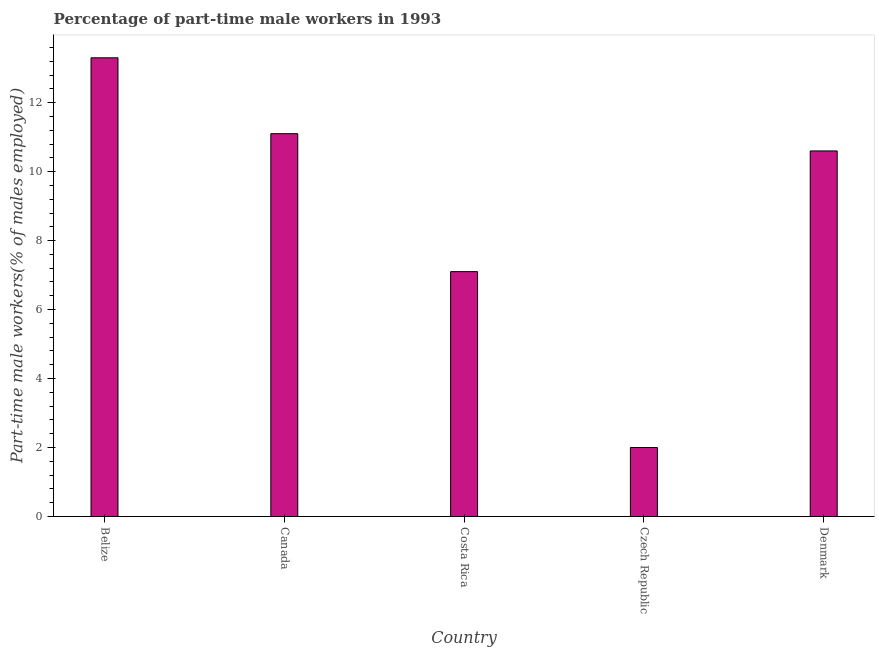Does the graph contain grids?
Provide a succinct answer. No. What is the title of the graph?
Ensure brevity in your answer.  Percentage of part-time male workers in 1993. What is the label or title of the Y-axis?
Provide a succinct answer. Part-time male workers(% of males employed). What is the percentage of part-time male workers in Costa Rica?
Offer a very short reply. 7.1. Across all countries, what is the maximum percentage of part-time male workers?
Ensure brevity in your answer.  13.3. Across all countries, what is the minimum percentage of part-time male workers?
Keep it short and to the point. 2. In which country was the percentage of part-time male workers maximum?
Your answer should be very brief. Belize. In which country was the percentage of part-time male workers minimum?
Make the answer very short. Czech Republic. What is the sum of the percentage of part-time male workers?
Your response must be concise. 44.1. What is the average percentage of part-time male workers per country?
Your answer should be very brief. 8.82. What is the median percentage of part-time male workers?
Offer a very short reply. 10.6. In how many countries, is the percentage of part-time male workers greater than 6.8 %?
Your answer should be very brief. 4. What is the ratio of the percentage of part-time male workers in Czech Republic to that in Denmark?
Provide a succinct answer. 0.19. Is the percentage of part-time male workers in Belize less than that in Canada?
Provide a succinct answer. No. What is the difference between the highest and the second highest percentage of part-time male workers?
Your answer should be compact. 2.2. Is the sum of the percentage of part-time male workers in Belize and Denmark greater than the maximum percentage of part-time male workers across all countries?
Ensure brevity in your answer.  Yes. What is the difference between the highest and the lowest percentage of part-time male workers?
Your response must be concise. 11.3. In how many countries, is the percentage of part-time male workers greater than the average percentage of part-time male workers taken over all countries?
Make the answer very short. 3. How many bars are there?
Offer a very short reply. 5. How many countries are there in the graph?
Offer a very short reply. 5. What is the difference between two consecutive major ticks on the Y-axis?
Your answer should be very brief. 2. Are the values on the major ticks of Y-axis written in scientific E-notation?
Provide a short and direct response. No. What is the Part-time male workers(% of males employed) of Belize?
Your answer should be very brief. 13.3. What is the Part-time male workers(% of males employed) in Canada?
Give a very brief answer. 11.1. What is the Part-time male workers(% of males employed) of Costa Rica?
Your response must be concise. 7.1. What is the Part-time male workers(% of males employed) of Czech Republic?
Your answer should be compact. 2. What is the Part-time male workers(% of males employed) in Denmark?
Your answer should be compact. 10.6. What is the difference between the Part-time male workers(% of males employed) in Belize and Czech Republic?
Make the answer very short. 11.3. What is the difference between the Part-time male workers(% of males employed) in Belize and Denmark?
Keep it short and to the point. 2.7. What is the difference between the Part-time male workers(% of males employed) in Costa Rica and Czech Republic?
Keep it short and to the point. 5.1. What is the difference between the Part-time male workers(% of males employed) in Costa Rica and Denmark?
Ensure brevity in your answer.  -3.5. What is the difference between the Part-time male workers(% of males employed) in Czech Republic and Denmark?
Provide a succinct answer. -8.6. What is the ratio of the Part-time male workers(% of males employed) in Belize to that in Canada?
Keep it short and to the point. 1.2. What is the ratio of the Part-time male workers(% of males employed) in Belize to that in Costa Rica?
Offer a very short reply. 1.87. What is the ratio of the Part-time male workers(% of males employed) in Belize to that in Czech Republic?
Your answer should be compact. 6.65. What is the ratio of the Part-time male workers(% of males employed) in Belize to that in Denmark?
Offer a terse response. 1.25. What is the ratio of the Part-time male workers(% of males employed) in Canada to that in Costa Rica?
Your answer should be compact. 1.56. What is the ratio of the Part-time male workers(% of males employed) in Canada to that in Czech Republic?
Your answer should be very brief. 5.55. What is the ratio of the Part-time male workers(% of males employed) in Canada to that in Denmark?
Ensure brevity in your answer.  1.05. What is the ratio of the Part-time male workers(% of males employed) in Costa Rica to that in Czech Republic?
Provide a succinct answer. 3.55. What is the ratio of the Part-time male workers(% of males employed) in Costa Rica to that in Denmark?
Give a very brief answer. 0.67. What is the ratio of the Part-time male workers(% of males employed) in Czech Republic to that in Denmark?
Your answer should be very brief. 0.19. 